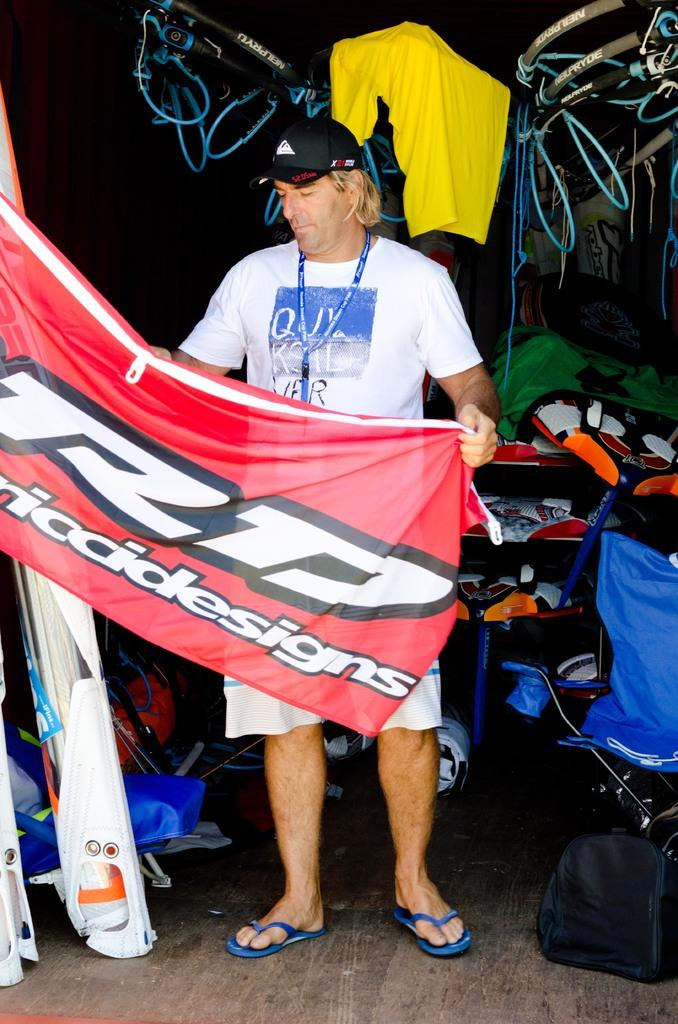<image>
Share a concise interpretation of the image provided. A man with a flag of RD seems some sort of sports flag. 